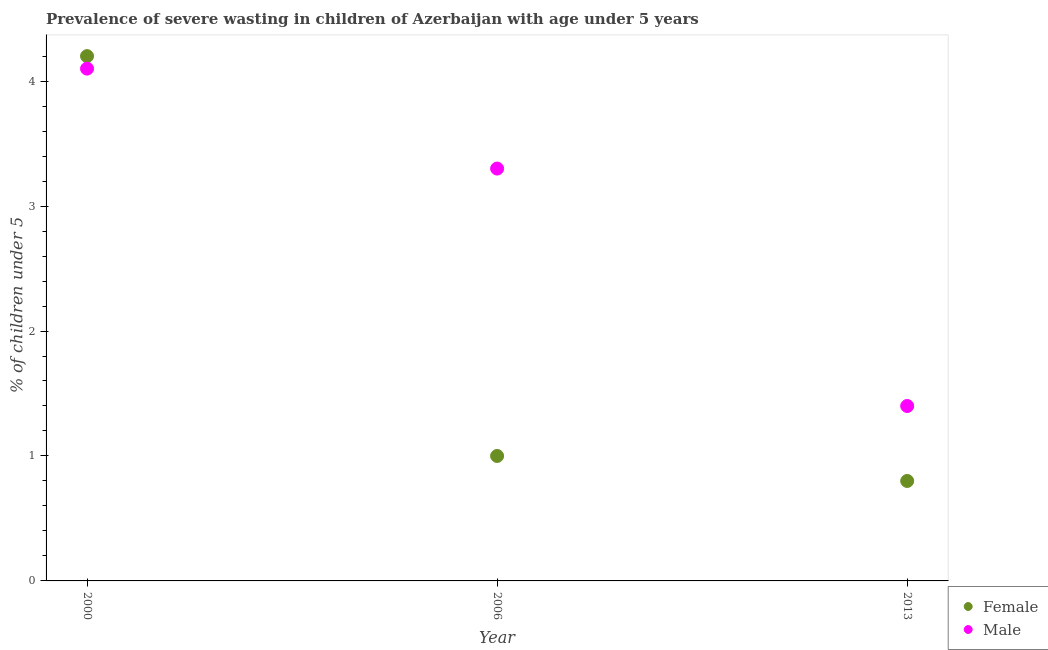What is the percentage of undernourished female children in 2000?
Provide a short and direct response. 4.2. Across all years, what is the maximum percentage of undernourished female children?
Keep it short and to the point. 4.2. Across all years, what is the minimum percentage of undernourished female children?
Ensure brevity in your answer.  0.8. In which year was the percentage of undernourished male children maximum?
Provide a short and direct response. 2000. In which year was the percentage of undernourished female children minimum?
Give a very brief answer. 2013. What is the total percentage of undernourished female children in the graph?
Your answer should be very brief. 6. What is the difference between the percentage of undernourished female children in 2000 and that in 2013?
Give a very brief answer. 3.4. What is the difference between the percentage of undernourished female children in 2013 and the percentage of undernourished male children in 2000?
Your answer should be very brief. -3.3. What is the average percentage of undernourished male children per year?
Ensure brevity in your answer.  2.93. In the year 2013, what is the difference between the percentage of undernourished male children and percentage of undernourished female children?
Offer a terse response. 0.6. What is the ratio of the percentage of undernourished female children in 2006 to that in 2013?
Ensure brevity in your answer.  1.25. What is the difference between the highest and the second highest percentage of undernourished male children?
Your response must be concise. 0.8. What is the difference between the highest and the lowest percentage of undernourished male children?
Provide a succinct answer. 2.7. Does the percentage of undernourished female children monotonically increase over the years?
Offer a very short reply. No. Is the percentage of undernourished female children strictly greater than the percentage of undernourished male children over the years?
Your response must be concise. No. How many dotlines are there?
Ensure brevity in your answer.  2. How many years are there in the graph?
Ensure brevity in your answer.  3. What is the difference between two consecutive major ticks on the Y-axis?
Provide a succinct answer. 1. Does the graph contain grids?
Offer a terse response. No. How are the legend labels stacked?
Provide a succinct answer. Vertical. What is the title of the graph?
Your answer should be very brief. Prevalence of severe wasting in children of Azerbaijan with age under 5 years. What is the label or title of the Y-axis?
Offer a very short reply.  % of children under 5. What is the  % of children under 5 in Female in 2000?
Give a very brief answer. 4.2. What is the  % of children under 5 of Male in 2000?
Offer a terse response. 4.1. What is the  % of children under 5 in Female in 2006?
Offer a very short reply. 1. What is the  % of children under 5 in Male in 2006?
Give a very brief answer. 3.3. What is the  % of children under 5 of Female in 2013?
Provide a succinct answer. 0.8. What is the  % of children under 5 of Male in 2013?
Make the answer very short. 1.4. Across all years, what is the maximum  % of children under 5 of Female?
Your answer should be compact. 4.2. Across all years, what is the maximum  % of children under 5 in Male?
Offer a very short reply. 4.1. Across all years, what is the minimum  % of children under 5 of Female?
Offer a terse response. 0.8. Across all years, what is the minimum  % of children under 5 in Male?
Give a very brief answer. 1.4. What is the total  % of children under 5 of Female in the graph?
Make the answer very short. 6. What is the difference between the  % of children under 5 in Male in 2000 and that in 2013?
Make the answer very short. 2.7. What is the difference between the  % of children under 5 of Female in 2000 and the  % of children under 5 of Male in 2006?
Give a very brief answer. 0.9. What is the average  % of children under 5 in Male per year?
Give a very brief answer. 2.93. In the year 2000, what is the difference between the  % of children under 5 in Female and  % of children under 5 in Male?
Your answer should be compact. 0.1. What is the ratio of the  % of children under 5 in Male in 2000 to that in 2006?
Offer a very short reply. 1.24. What is the ratio of the  % of children under 5 in Female in 2000 to that in 2013?
Provide a short and direct response. 5.25. What is the ratio of the  % of children under 5 in Male in 2000 to that in 2013?
Provide a succinct answer. 2.93. What is the ratio of the  % of children under 5 of Female in 2006 to that in 2013?
Keep it short and to the point. 1.25. What is the ratio of the  % of children under 5 in Male in 2006 to that in 2013?
Offer a terse response. 2.36. What is the difference between the highest and the second highest  % of children under 5 in Female?
Keep it short and to the point. 3.2. What is the difference between the highest and the second highest  % of children under 5 in Male?
Provide a succinct answer. 0.8. What is the difference between the highest and the lowest  % of children under 5 of Male?
Provide a short and direct response. 2.7. 